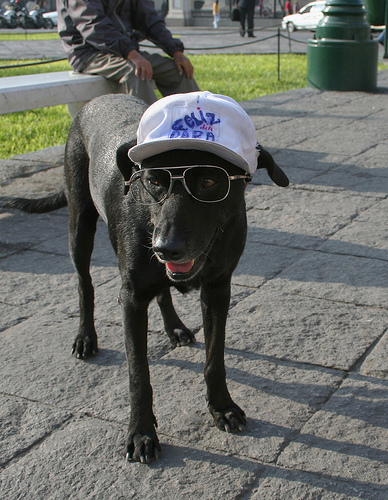What kind of accessory is the dog wearing on its head? The dog is wearing a white cap with a logo on its head which adds to its charming and quirky look. 